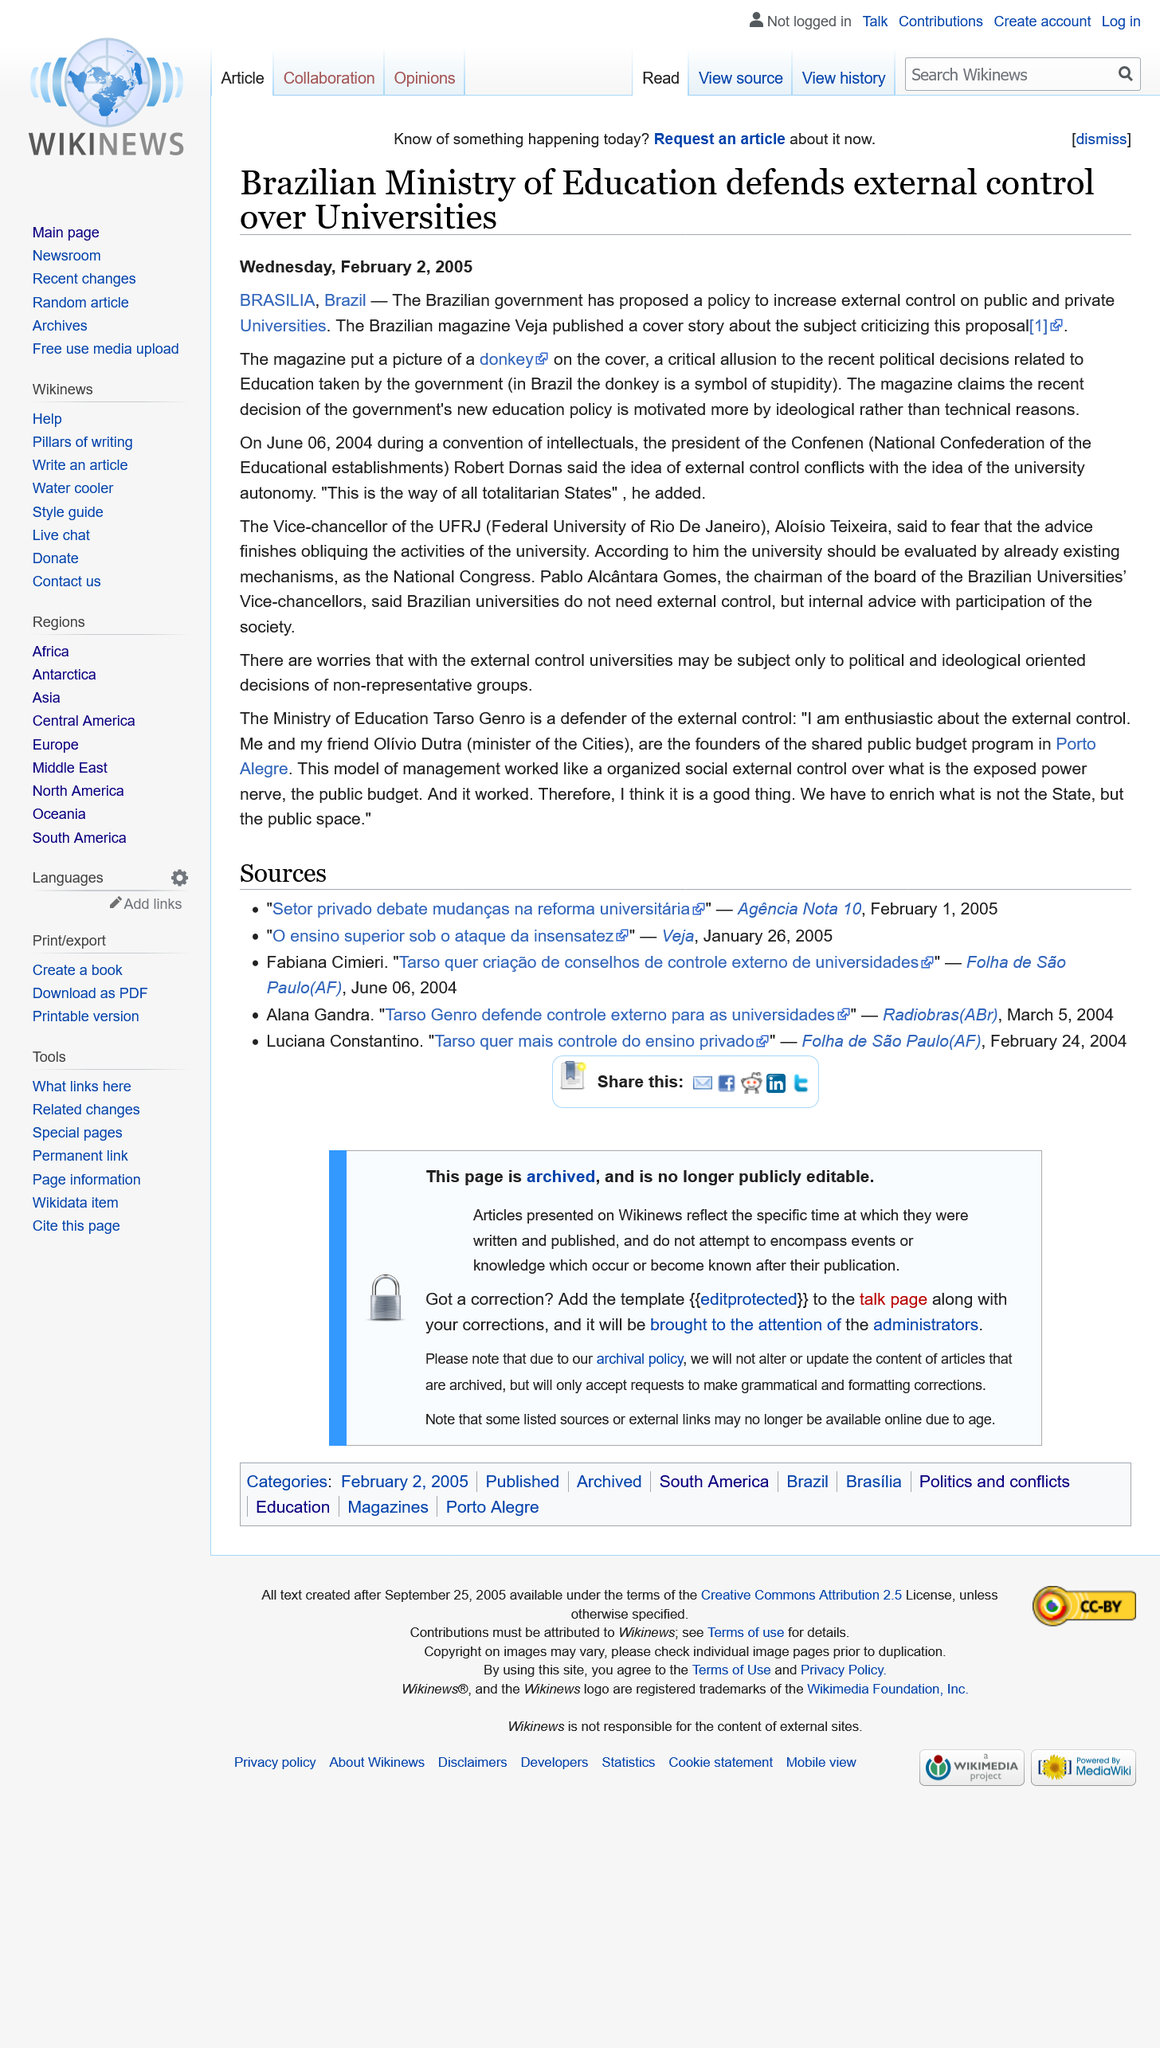Point out several critical features in this image. With certainty, I can affirm that the president of the Conference is none other than Robert Dornas. The article "Brazilian Ministry of Education defends external control over Universities" was published on Wednesday, February 2, 2005. I declare that Confenen stands for the National Confederation of the Educational Establishments, representing a unified voice for the education community. 